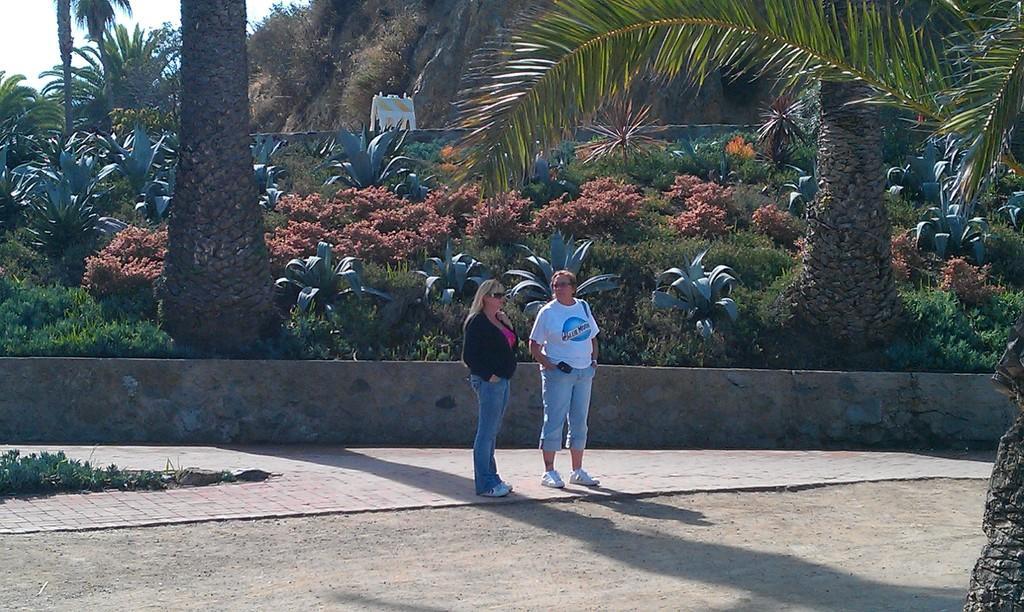How would you summarize this image in a sentence or two? In this image we can see two women are standing on a footpath. In the background there are trees, plants and sky. 